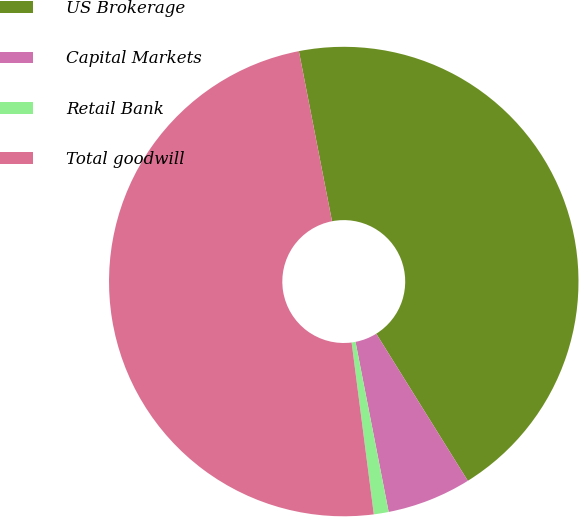Convert chart to OTSL. <chart><loc_0><loc_0><loc_500><loc_500><pie_chart><fcel>US Brokerage<fcel>Capital Markets<fcel>Retail Bank<fcel>Total goodwill<nl><fcel>44.2%<fcel>5.8%<fcel>1.02%<fcel>48.98%<nl></chart> 